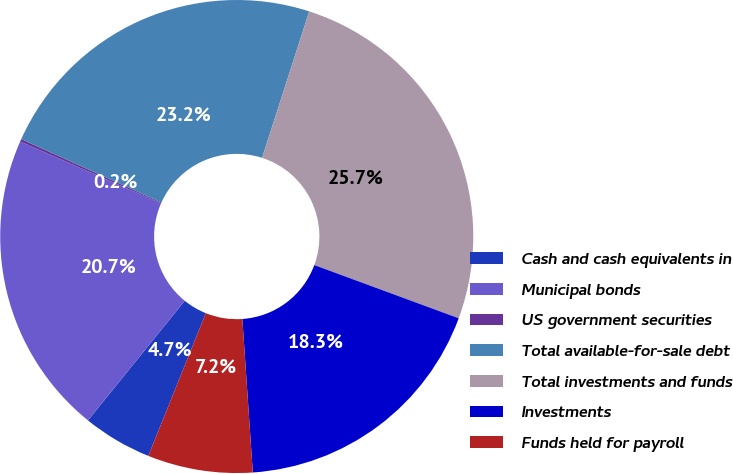Convert chart to OTSL. <chart><loc_0><loc_0><loc_500><loc_500><pie_chart><fcel>Cash and cash equivalents in<fcel>Municipal bonds<fcel>US government securities<fcel>Total available-for-sale debt<fcel>Total investments and funds<fcel>Investments<fcel>Funds held for payroll<nl><fcel>4.73%<fcel>20.75%<fcel>0.18%<fcel>23.2%<fcel>25.66%<fcel>18.3%<fcel>7.18%<nl></chart> 